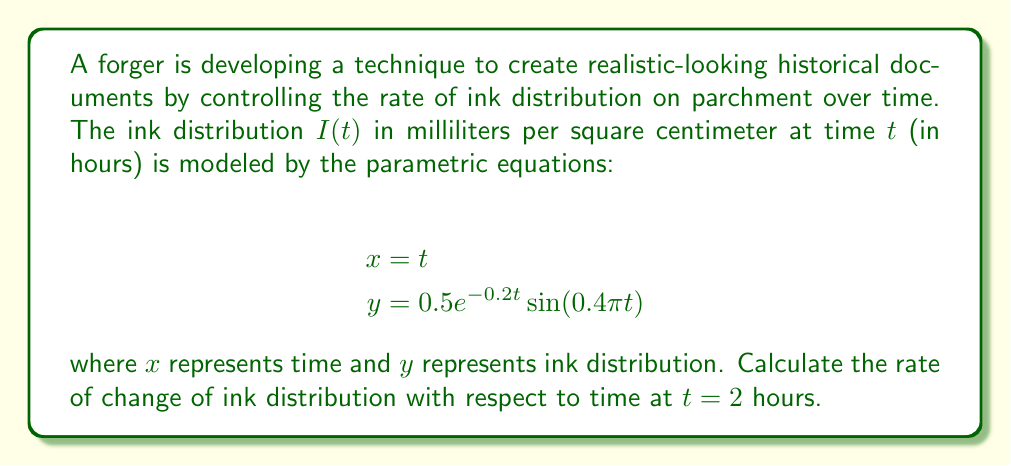Solve this math problem. To solve this problem, we need to find $\frac{dy}{dx}$ at $t = 2$. Since we have parametric equations, we'll use the chain rule:

$$\frac{dy}{dx} = \frac{dy/dt}{dx/dt}$$

1. First, let's find $\frac{dx}{dt}$:
   $$\frac{dx}{dt} = 1$$

2. Next, we'll find $\frac{dy}{dt}$:
   $$\begin{align}
   y &= 0.5e^{-0.2t}\sin(0.4\pi t) \\
   \frac{dy}{dt} &= 0.5[-0.2e^{-0.2t}\sin(0.4\pi t) + e^{-0.2t}(0.4\pi)\cos(0.4\pi t)] \\
   &= 0.5e^{-0.2t}[-0.2\sin(0.4\pi t) + 0.4\pi\cos(0.4\pi t)]
   \end{align}$$

3. Now we can calculate $\frac{dy}{dx}$:
   $$\frac{dy}{dx} = \frac{dy/dt}{dx/dt} = \frac{0.5e^{-0.2t}[-0.2\sin(0.4\pi t) + 0.4\pi\cos(0.4\pi t)]}{1}$$

4. Evaluate at $t = 2$:
   $$\begin{align}
   \frac{dy}{dx}\bigg|_{t=2} &= 0.5e^{-0.4}[-0.2\sin(0.8\pi) + 0.4\pi\cos(0.8\pi)] \\
   &\approx 0.5 \cdot 0.6703 \cdot [-0.2 \cdot 0.9511 + 0.4\pi \cdot (-0.3090)] \\
   &\approx 0.3352 \cdot [-0.1902 - 0.3879] \\
   &\approx -0.1939
   \end{align}$$
Answer: The rate of change of ink distribution with respect to time at $t = 2$ hours is approximately $-0.1939$ mL/cm²/hour. 